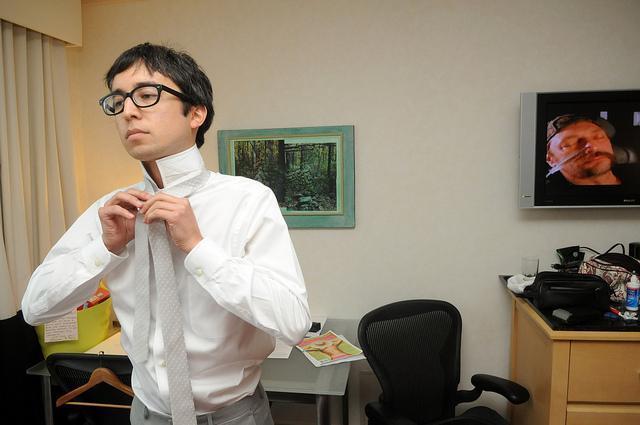How many people are visible?
Give a very brief answer. 2. How many chairs can you see?
Give a very brief answer. 2. How many tents in this image are to the left of the rainbow-colored umbrella at the end of the wooden walkway?
Give a very brief answer. 0. 